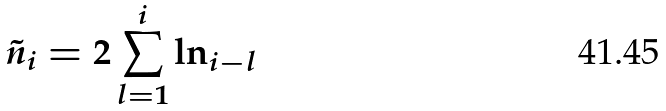Convert formula to latex. <formula><loc_0><loc_0><loc_500><loc_500>\tilde { n } _ { i } = 2 \sum _ { l = 1 } ^ { i } \ln _ { i - l }</formula> 